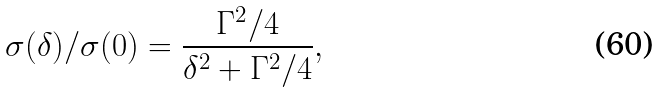Convert formula to latex. <formula><loc_0><loc_0><loc_500><loc_500>\sigma ( \delta ) / \sigma ( 0 ) = \frac { \Gamma ^ { 2 } / 4 } { \delta ^ { 2 } + \Gamma ^ { 2 } / 4 } ,</formula> 